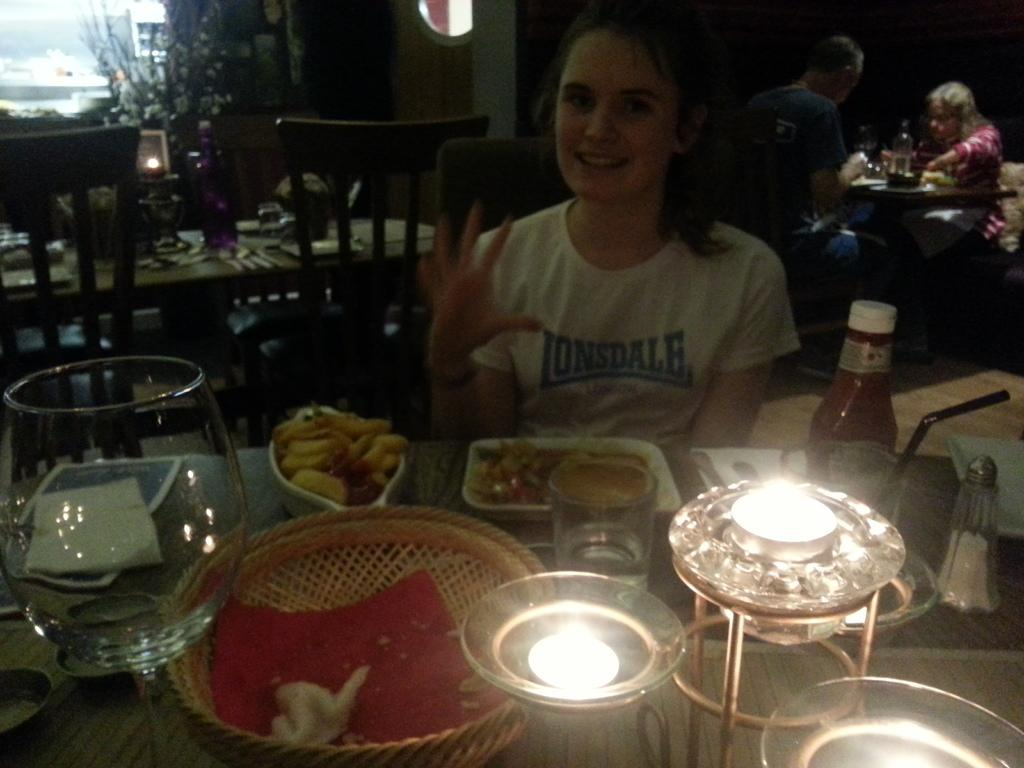How many persons are sitting in the image? There are three persons sitting on chairs in the image. What is present on the table in the image? On the table, there is a bowl, a plate, a basket, a glass, a lamp, and a ketchup bottle. What type of food is visible on the table? There is food on the table, but the specific type of food is not mentioned in the facts. What can be seen in the background of the image? There is a wall and a plant in the background of the image. What type of cracker is being used to mark the territory in the image? There is no mention of crackers or territory in the image. What type of spade is being used to dig in the background of the image? There is no spade or digging activity present in the image. 